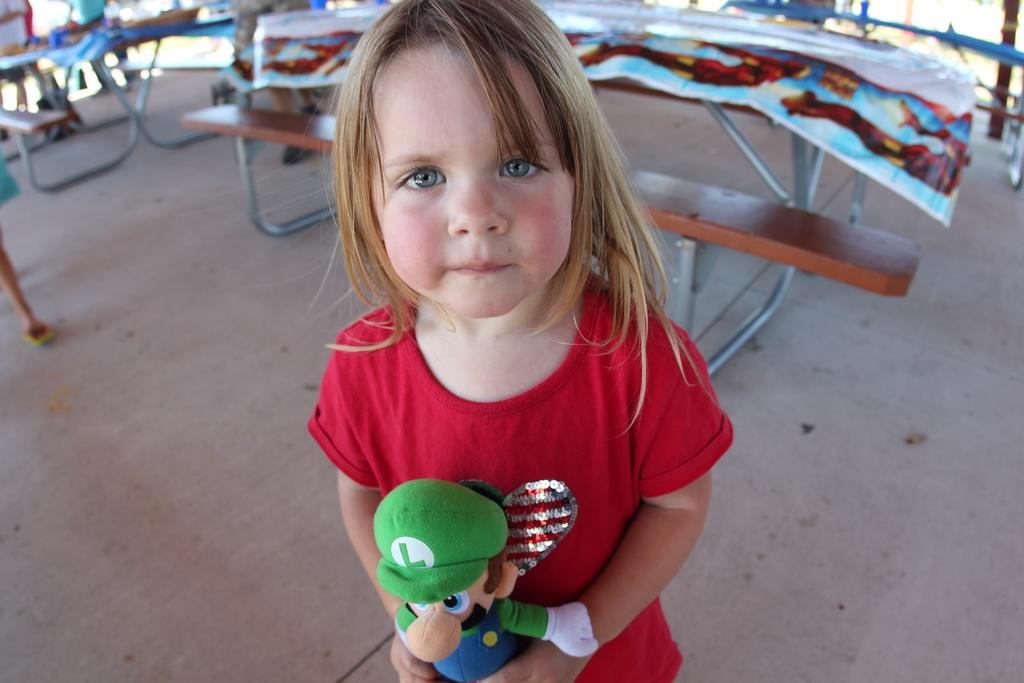Who is the main subject in the image? There is a girl in the image. What is the girl wearing? The girl is wearing a red T-shirt. What is the girl holding in her hand? The girl is holding a toy in her hand. What can be seen in the background of the image? There are benches and a floor visible in the background of the image. Can you describe the kiss between the girl and the boy in the image? There is no boy present in the image, and the girl is not kissing anyone. 